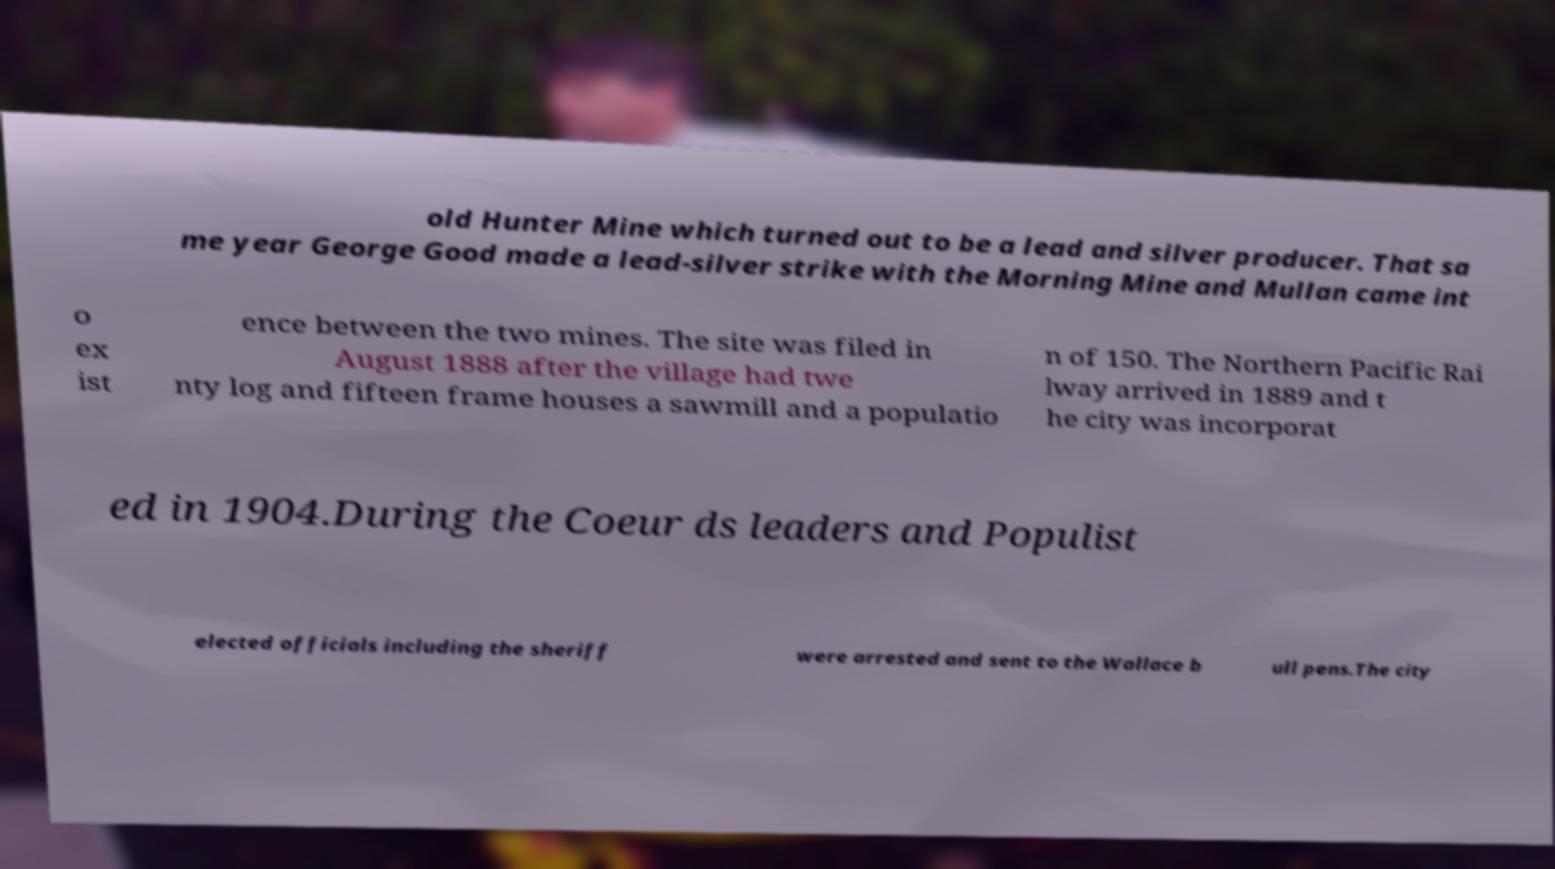There's text embedded in this image that I need extracted. Can you transcribe it verbatim? old Hunter Mine which turned out to be a lead and silver producer. That sa me year George Good made a lead-silver strike with the Morning Mine and Mullan came int o ex ist ence between the two mines. The site was filed in August 1888 after the village had twe nty log and fifteen frame houses a sawmill and a populatio n of 150. The Northern Pacific Rai lway arrived in 1889 and t he city was incorporat ed in 1904.During the Coeur ds leaders and Populist elected officials including the sheriff were arrested and sent to the Wallace b ull pens.The city 